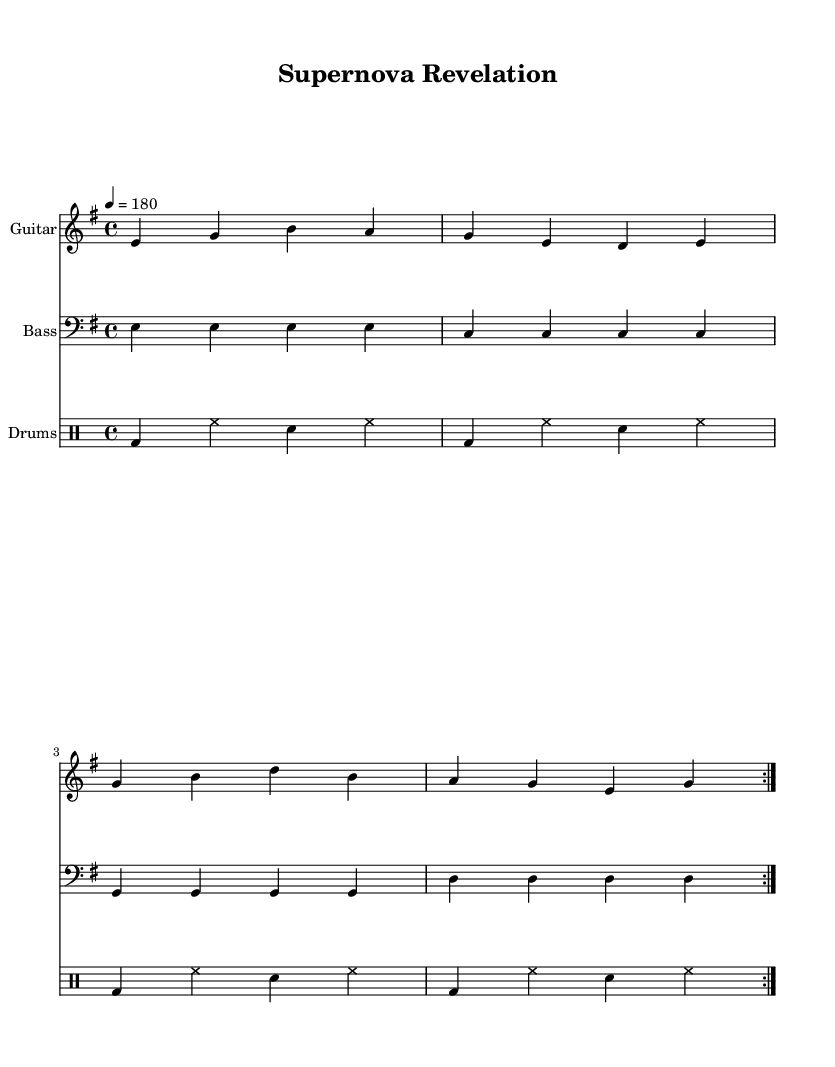What is the key signature of this music? The key signature shows one sharp, indicating it is in E minor.
Answer: E minor What is the time signature of this piece? The time signature is indicated at the beginning of the score and shown as 4/4, which means there are four beats per measure.
Answer: 4/4 What is the tempo marking for this piece? The tempo is specified in the score as quarter note equals 180, indicating a fast pace.
Answer: 180 How many times is the musical section repeated? The directives in the score indicate that the sections are repeated two times, as noted by the repeat voltas.
Answer: 2 What instruments are featured in this composition? The score clearly lists three different instruments: Guitar, Bass, and Drums.
Answer: Guitar, Bass, Drums What genre does this musical piece belong to? The overall style and the high-energy lyrics indicate that it falls under the Punk genre, characterized by fast tempos and anthemic qualities.
Answer: Punk 